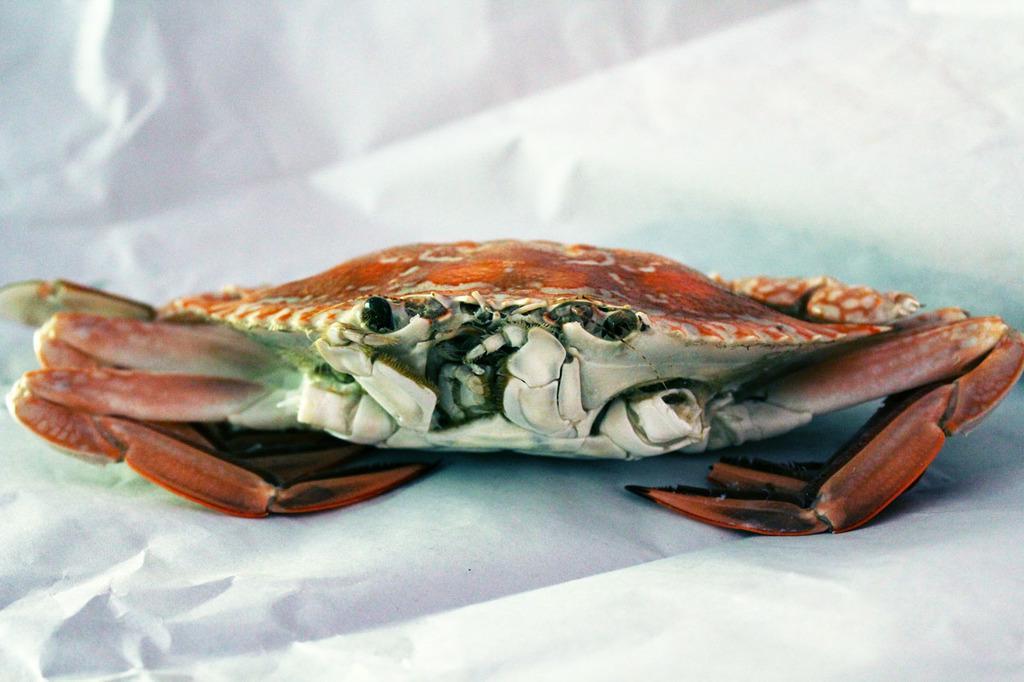Could you give a brief overview of what you see in this image? In this image I can see a crab on a white paper. 